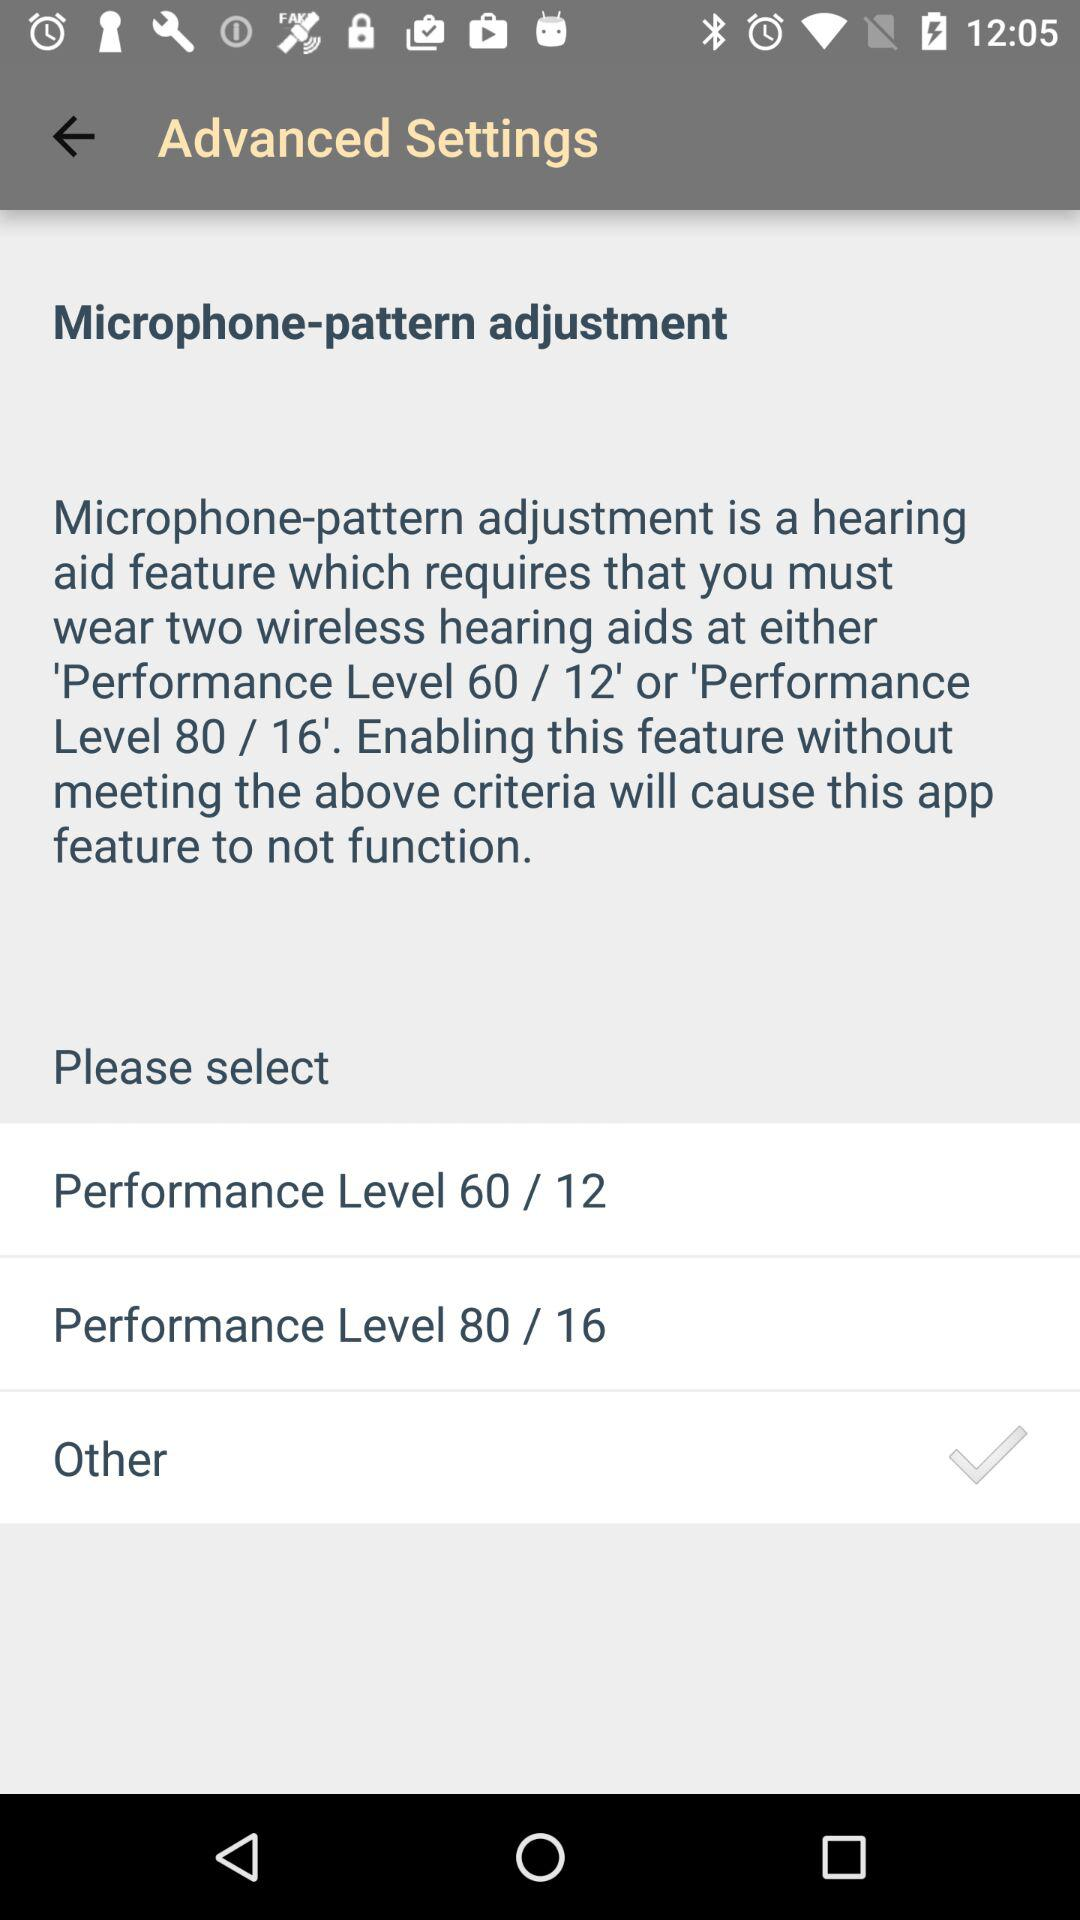How many of the performance levels require that you wear two wireless hearing aids?
Answer the question using a single word or phrase. 2 